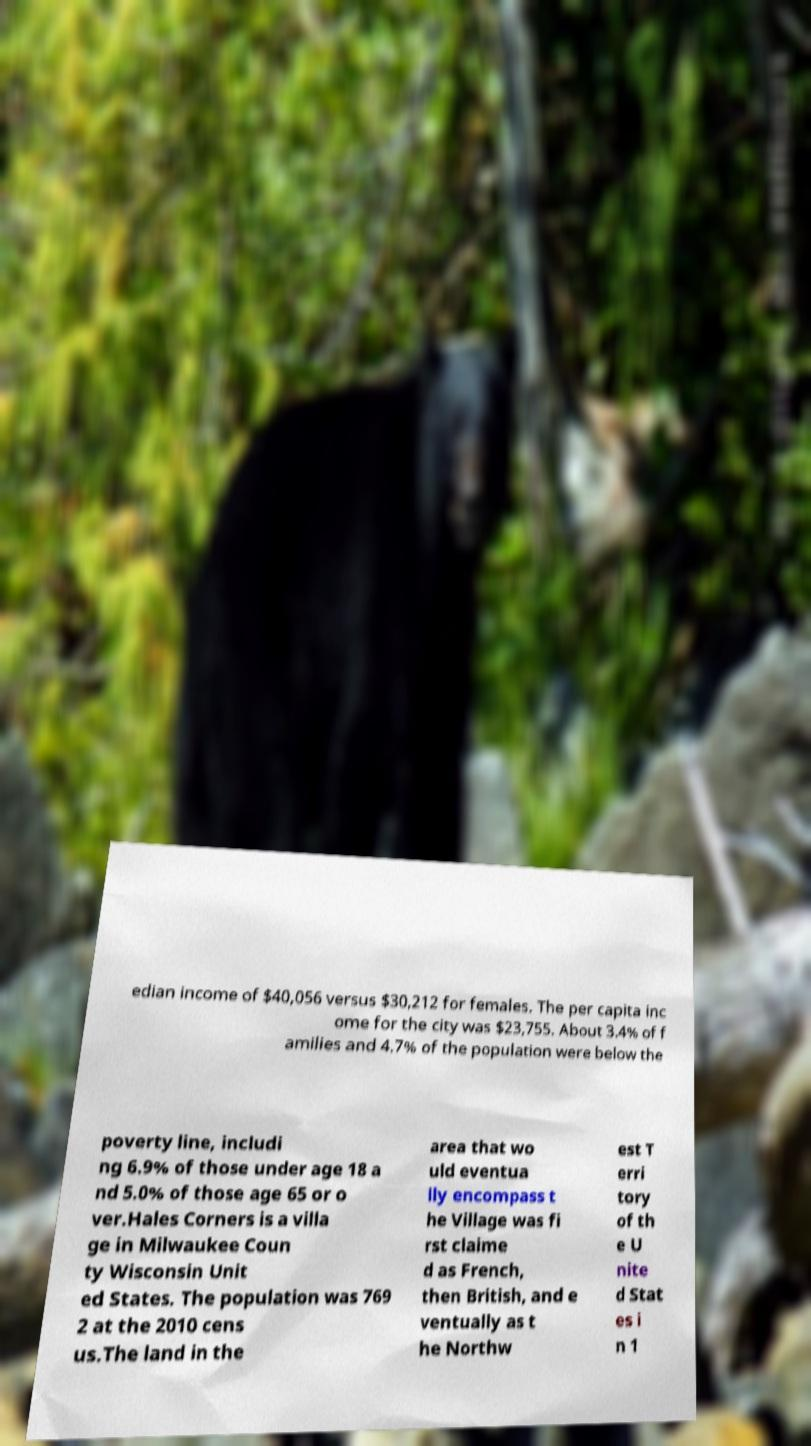What messages or text are displayed in this image? I need them in a readable, typed format. edian income of $40,056 versus $30,212 for females. The per capita inc ome for the city was $23,755. About 3.4% of f amilies and 4.7% of the population were below the poverty line, includi ng 6.9% of those under age 18 a nd 5.0% of those age 65 or o ver.Hales Corners is a villa ge in Milwaukee Coun ty Wisconsin Unit ed States. The population was 769 2 at the 2010 cens us.The land in the area that wo uld eventua lly encompass t he Village was fi rst claime d as French, then British, and e ventually as t he Northw est T erri tory of th e U nite d Stat es i n 1 